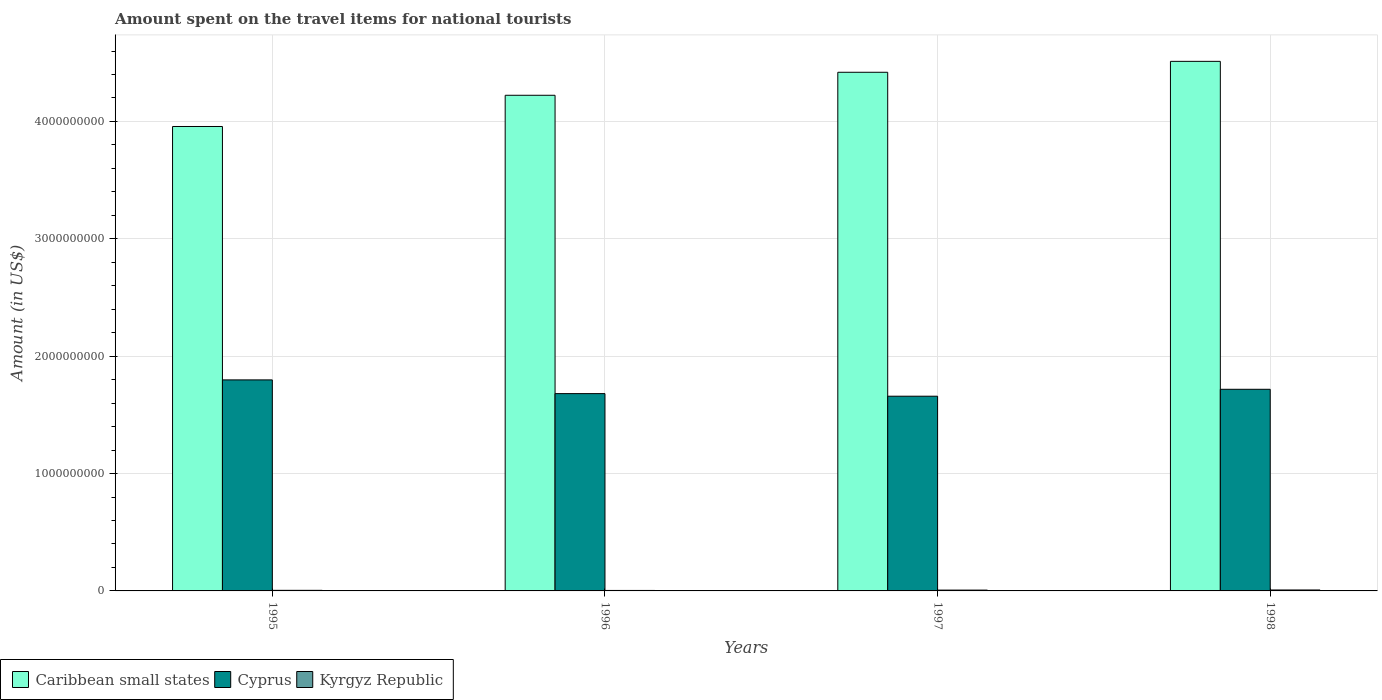Are the number of bars per tick equal to the number of legend labels?
Your answer should be compact. Yes. How many bars are there on the 2nd tick from the right?
Offer a very short reply. 3. In how many cases, is the number of bars for a given year not equal to the number of legend labels?
Your answer should be very brief. 0. What is the amount spent on the travel items for national tourists in Kyrgyz Republic in 1997?
Provide a succinct answer. 7.00e+06. Across all years, what is the maximum amount spent on the travel items for national tourists in Kyrgyz Republic?
Provide a short and direct response. 8.00e+06. Across all years, what is the minimum amount spent on the travel items for national tourists in Kyrgyz Republic?
Your answer should be compact. 4.00e+06. In which year was the amount spent on the travel items for national tourists in Kyrgyz Republic minimum?
Your answer should be compact. 1996. What is the total amount spent on the travel items for national tourists in Kyrgyz Republic in the graph?
Ensure brevity in your answer.  2.40e+07. What is the difference between the amount spent on the travel items for national tourists in Cyprus in 1995 and that in 1996?
Make the answer very short. 1.17e+08. What is the difference between the amount spent on the travel items for national tourists in Kyrgyz Republic in 1997 and the amount spent on the travel items for national tourists in Cyprus in 1995?
Your answer should be very brief. -1.79e+09. What is the average amount spent on the travel items for national tourists in Cyprus per year?
Your answer should be compact. 1.71e+09. In the year 1997, what is the difference between the amount spent on the travel items for national tourists in Cyprus and amount spent on the travel items for national tourists in Caribbean small states?
Offer a very short reply. -2.76e+09. What is the ratio of the amount spent on the travel items for national tourists in Caribbean small states in 1995 to that in 1997?
Your answer should be very brief. 0.9. Is the amount spent on the travel items for national tourists in Cyprus in 1997 less than that in 1998?
Your response must be concise. Yes. Is the difference between the amount spent on the travel items for national tourists in Cyprus in 1995 and 1997 greater than the difference between the amount spent on the travel items for national tourists in Caribbean small states in 1995 and 1997?
Keep it short and to the point. Yes. What is the difference between the highest and the second highest amount spent on the travel items for national tourists in Caribbean small states?
Your response must be concise. 9.30e+07. What is the difference between the highest and the lowest amount spent on the travel items for national tourists in Caribbean small states?
Offer a very short reply. 5.55e+08. In how many years, is the amount spent on the travel items for national tourists in Caribbean small states greater than the average amount spent on the travel items for national tourists in Caribbean small states taken over all years?
Your answer should be very brief. 2. Is the sum of the amount spent on the travel items for national tourists in Caribbean small states in 1995 and 1997 greater than the maximum amount spent on the travel items for national tourists in Kyrgyz Republic across all years?
Your response must be concise. Yes. What does the 3rd bar from the left in 1996 represents?
Give a very brief answer. Kyrgyz Republic. What does the 2nd bar from the right in 1997 represents?
Your answer should be compact. Cyprus. Is it the case that in every year, the sum of the amount spent on the travel items for national tourists in Cyprus and amount spent on the travel items for national tourists in Kyrgyz Republic is greater than the amount spent on the travel items for national tourists in Caribbean small states?
Offer a terse response. No. How many years are there in the graph?
Make the answer very short. 4. How many legend labels are there?
Provide a succinct answer. 3. How are the legend labels stacked?
Keep it short and to the point. Horizontal. What is the title of the graph?
Your answer should be very brief. Amount spent on the travel items for national tourists. What is the label or title of the X-axis?
Provide a short and direct response. Years. What is the Amount (in US$) in Caribbean small states in 1995?
Offer a very short reply. 3.96e+09. What is the Amount (in US$) in Cyprus in 1995?
Make the answer very short. 1.80e+09. What is the Amount (in US$) of Caribbean small states in 1996?
Your answer should be compact. 4.22e+09. What is the Amount (in US$) of Cyprus in 1996?
Your response must be concise. 1.68e+09. What is the Amount (in US$) of Caribbean small states in 1997?
Your response must be concise. 4.42e+09. What is the Amount (in US$) of Cyprus in 1997?
Give a very brief answer. 1.66e+09. What is the Amount (in US$) in Kyrgyz Republic in 1997?
Your answer should be compact. 7.00e+06. What is the Amount (in US$) of Caribbean small states in 1998?
Offer a very short reply. 4.51e+09. What is the Amount (in US$) of Cyprus in 1998?
Offer a very short reply. 1.72e+09. Across all years, what is the maximum Amount (in US$) in Caribbean small states?
Offer a terse response. 4.51e+09. Across all years, what is the maximum Amount (in US$) of Cyprus?
Keep it short and to the point. 1.80e+09. Across all years, what is the minimum Amount (in US$) in Caribbean small states?
Ensure brevity in your answer.  3.96e+09. Across all years, what is the minimum Amount (in US$) in Cyprus?
Your answer should be compact. 1.66e+09. What is the total Amount (in US$) of Caribbean small states in the graph?
Your response must be concise. 1.71e+1. What is the total Amount (in US$) in Cyprus in the graph?
Your answer should be very brief. 6.86e+09. What is the total Amount (in US$) in Kyrgyz Republic in the graph?
Offer a terse response. 2.40e+07. What is the difference between the Amount (in US$) of Caribbean small states in 1995 and that in 1996?
Ensure brevity in your answer.  -2.66e+08. What is the difference between the Amount (in US$) of Cyprus in 1995 and that in 1996?
Provide a succinct answer. 1.17e+08. What is the difference between the Amount (in US$) in Caribbean small states in 1995 and that in 1997?
Ensure brevity in your answer.  -4.62e+08. What is the difference between the Amount (in US$) in Cyprus in 1995 and that in 1997?
Give a very brief answer. 1.39e+08. What is the difference between the Amount (in US$) of Kyrgyz Republic in 1995 and that in 1997?
Provide a short and direct response. -2.00e+06. What is the difference between the Amount (in US$) in Caribbean small states in 1995 and that in 1998?
Offer a terse response. -5.55e+08. What is the difference between the Amount (in US$) of Cyprus in 1995 and that in 1998?
Make the answer very short. 8.00e+07. What is the difference between the Amount (in US$) of Kyrgyz Republic in 1995 and that in 1998?
Ensure brevity in your answer.  -3.00e+06. What is the difference between the Amount (in US$) of Caribbean small states in 1996 and that in 1997?
Your response must be concise. -1.96e+08. What is the difference between the Amount (in US$) in Cyprus in 1996 and that in 1997?
Keep it short and to the point. 2.20e+07. What is the difference between the Amount (in US$) of Caribbean small states in 1996 and that in 1998?
Make the answer very short. -2.89e+08. What is the difference between the Amount (in US$) of Cyprus in 1996 and that in 1998?
Give a very brief answer. -3.70e+07. What is the difference between the Amount (in US$) of Caribbean small states in 1997 and that in 1998?
Provide a short and direct response. -9.30e+07. What is the difference between the Amount (in US$) in Cyprus in 1997 and that in 1998?
Offer a terse response. -5.90e+07. What is the difference between the Amount (in US$) of Caribbean small states in 1995 and the Amount (in US$) of Cyprus in 1996?
Ensure brevity in your answer.  2.28e+09. What is the difference between the Amount (in US$) of Caribbean small states in 1995 and the Amount (in US$) of Kyrgyz Republic in 1996?
Your response must be concise. 3.95e+09. What is the difference between the Amount (in US$) of Cyprus in 1995 and the Amount (in US$) of Kyrgyz Republic in 1996?
Offer a terse response. 1.79e+09. What is the difference between the Amount (in US$) in Caribbean small states in 1995 and the Amount (in US$) in Cyprus in 1997?
Offer a very short reply. 2.30e+09. What is the difference between the Amount (in US$) of Caribbean small states in 1995 and the Amount (in US$) of Kyrgyz Republic in 1997?
Make the answer very short. 3.95e+09. What is the difference between the Amount (in US$) in Cyprus in 1995 and the Amount (in US$) in Kyrgyz Republic in 1997?
Ensure brevity in your answer.  1.79e+09. What is the difference between the Amount (in US$) of Caribbean small states in 1995 and the Amount (in US$) of Cyprus in 1998?
Your answer should be compact. 2.24e+09. What is the difference between the Amount (in US$) in Caribbean small states in 1995 and the Amount (in US$) in Kyrgyz Republic in 1998?
Provide a succinct answer. 3.95e+09. What is the difference between the Amount (in US$) of Cyprus in 1995 and the Amount (in US$) of Kyrgyz Republic in 1998?
Offer a very short reply. 1.79e+09. What is the difference between the Amount (in US$) in Caribbean small states in 1996 and the Amount (in US$) in Cyprus in 1997?
Provide a short and direct response. 2.56e+09. What is the difference between the Amount (in US$) of Caribbean small states in 1996 and the Amount (in US$) of Kyrgyz Republic in 1997?
Offer a very short reply. 4.22e+09. What is the difference between the Amount (in US$) in Cyprus in 1996 and the Amount (in US$) in Kyrgyz Republic in 1997?
Offer a very short reply. 1.67e+09. What is the difference between the Amount (in US$) in Caribbean small states in 1996 and the Amount (in US$) in Cyprus in 1998?
Offer a terse response. 2.50e+09. What is the difference between the Amount (in US$) in Caribbean small states in 1996 and the Amount (in US$) in Kyrgyz Republic in 1998?
Your answer should be very brief. 4.22e+09. What is the difference between the Amount (in US$) in Cyprus in 1996 and the Amount (in US$) in Kyrgyz Republic in 1998?
Provide a succinct answer. 1.67e+09. What is the difference between the Amount (in US$) of Caribbean small states in 1997 and the Amount (in US$) of Cyprus in 1998?
Provide a succinct answer. 2.70e+09. What is the difference between the Amount (in US$) of Caribbean small states in 1997 and the Amount (in US$) of Kyrgyz Republic in 1998?
Offer a terse response. 4.41e+09. What is the difference between the Amount (in US$) in Cyprus in 1997 and the Amount (in US$) in Kyrgyz Republic in 1998?
Ensure brevity in your answer.  1.65e+09. What is the average Amount (in US$) in Caribbean small states per year?
Your response must be concise. 4.28e+09. What is the average Amount (in US$) in Cyprus per year?
Provide a short and direct response. 1.71e+09. In the year 1995, what is the difference between the Amount (in US$) in Caribbean small states and Amount (in US$) in Cyprus?
Give a very brief answer. 2.16e+09. In the year 1995, what is the difference between the Amount (in US$) of Caribbean small states and Amount (in US$) of Kyrgyz Republic?
Provide a short and direct response. 3.95e+09. In the year 1995, what is the difference between the Amount (in US$) in Cyprus and Amount (in US$) in Kyrgyz Republic?
Your response must be concise. 1.79e+09. In the year 1996, what is the difference between the Amount (in US$) in Caribbean small states and Amount (in US$) in Cyprus?
Provide a short and direct response. 2.54e+09. In the year 1996, what is the difference between the Amount (in US$) in Caribbean small states and Amount (in US$) in Kyrgyz Republic?
Offer a terse response. 4.22e+09. In the year 1996, what is the difference between the Amount (in US$) in Cyprus and Amount (in US$) in Kyrgyz Republic?
Your response must be concise. 1.68e+09. In the year 1997, what is the difference between the Amount (in US$) in Caribbean small states and Amount (in US$) in Cyprus?
Keep it short and to the point. 2.76e+09. In the year 1997, what is the difference between the Amount (in US$) in Caribbean small states and Amount (in US$) in Kyrgyz Republic?
Provide a succinct answer. 4.41e+09. In the year 1997, what is the difference between the Amount (in US$) of Cyprus and Amount (in US$) of Kyrgyz Republic?
Keep it short and to the point. 1.65e+09. In the year 1998, what is the difference between the Amount (in US$) in Caribbean small states and Amount (in US$) in Cyprus?
Offer a terse response. 2.79e+09. In the year 1998, what is the difference between the Amount (in US$) of Caribbean small states and Amount (in US$) of Kyrgyz Republic?
Your response must be concise. 4.50e+09. In the year 1998, what is the difference between the Amount (in US$) of Cyprus and Amount (in US$) of Kyrgyz Republic?
Offer a very short reply. 1.71e+09. What is the ratio of the Amount (in US$) of Caribbean small states in 1995 to that in 1996?
Offer a very short reply. 0.94. What is the ratio of the Amount (in US$) in Cyprus in 1995 to that in 1996?
Offer a terse response. 1.07. What is the ratio of the Amount (in US$) of Caribbean small states in 1995 to that in 1997?
Keep it short and to the point. 0.9. What is the ratio of the Amount (in US$) in Cyprus in 1995 to that in 1997?
Ensure brevity in your answer.  1.08. What is the ratio of the Amount (in US$) in Kyrgyz Republic in 1995 to that in 1997?
Your response must be concise. 0.71. What is the ratio of the Amount (in US$) of Caribbean small states in 1995 to that in 1998?
Your answer should be very brief. 0.88. What is the ratio of the Amount (in US$) in Cyprus in 1995 to that in 1998?
Offer a terse response. 1.05. What is the ratio of the Amount (in US$) in Kyrgyz Republic in 1995 to that in 1998?
Offer a terse response. 0.62. What is the ratio of the Amount (in US$) of Caribbean small states in 1996 to that in 1997?
Your response must be concise. 0.96. What is the ratio of the Amount (in US$) in Cyprus in 1996 to that in 1997?
Give a very brief answer. 1.01. What is the ratio of the Amount (in US$) of Caribbean small states in 1996 to that in 1998?
Keep it short and to the point. 0.94. What is the ratio of the Amount (in US$) in Cyprus in 1996 to that in 1998?
Your answer should be very brief. 0.98. What is the ratio of the Amount (in US$) of Kyrgyz Republic in 1996 to that in 1998?
Your response must be concise. 0.5. What is the ratio of the Amount (in US$) of Caribbean small states in 1997 to that in 1998?
Your answer should be compact. 0.98. What is the ratio of the Amount (in US$) of Cyprus in 1997 to that in 1998?
Your response must be concise. 0.97. What is the ratio of the Amount (in US$) of Kyrgyz Republic in 1997 to that in 1998?
Give a very brief answer. 0.88. What is the difference between the highest and the second highest Amount (in US$) of Caribbean small states?
Your answer should be compact. 9.30e+07. What is the difference between the highest and the second highest Amount (in US$) of Cyprus?
Offer a very short reply. 8.00e+07. What is the difference between the highest and the second highest Amount (in US$) of Kyrgyz Republic?
Provide a succinct answer. 1.00e+06. What is the difference between the highest and the lowest Amount (in US$) in Caribbean small states?
Make the answer very short. 5.55e+08. What is the difference between the highest and the lowest Amount (in US$) in Cyprus?
Give a very brief answer. 1.39e+08. 